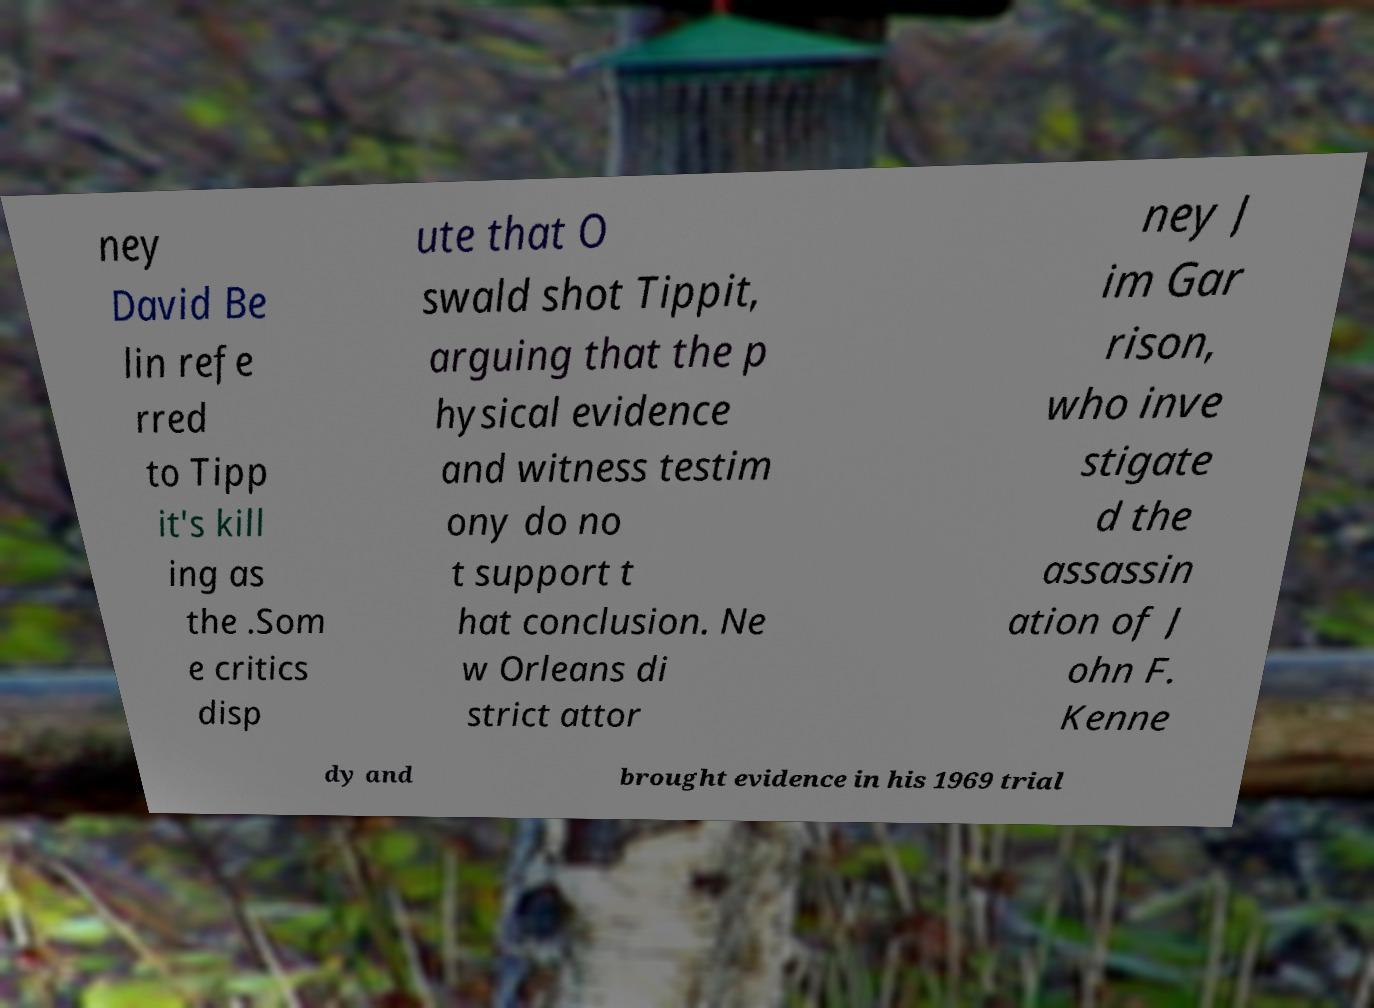For documentation purposes, I need the text within this image transcribed. Could you provide that? ney David Be lin refe rred to Tipp it's kill ing as the .Som e critics disp ute that O swald shot Tippit, arguing that the p hysical evidence and witness testim ony do no t support t hat conclusion. Ne w Orleans di strict attor ney J im Gar rison, who inve stigate d the assassin ation of J ohn F. Kenne dy and brought evidence in his 1969 trial 